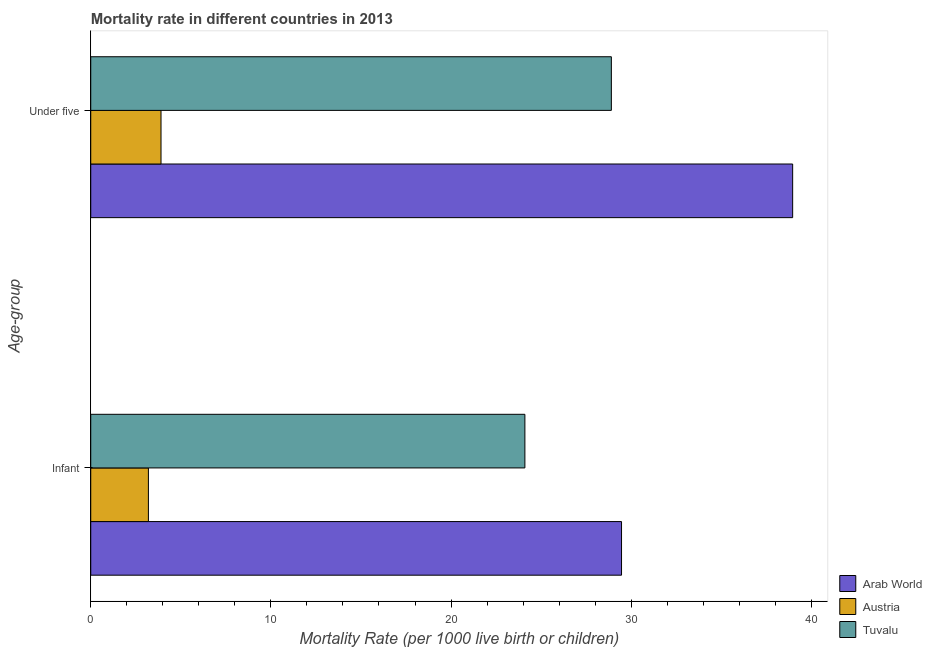Are the number of bars per tick equal to the number of legend labels?
Ensure brevity in your answer.  Yes. How many bars are there on the 1st tick from the top?
Offer a terse response. 3. How many bars are there on the 2nd tick from the bottom?
Give a very brief answer. 3. What is the label of the 1st group of bars from the top?
Keep it short and to the point. Under five. What is the infant mortality rate in Arab World?
Offer a terse response. 29.46. Across all countries, what is the maximum under-5 mortality rate?
Offer a very short reply. 38.96. In which country was the infant mortality rate maximum?
Ensure brevity in your answer.  Arab World. In which country was the infant mortality rate minimum?
Provide a short and direct response. Austria. What is the total infant mortality rate in the graph?
Your response must be concise. 56.76. What is the difference between the under-5 mortality rate in Austria and that in Arab World?
Your response must be concise. -35.06. What is the difference between the infant mortality rate in Austria and the under-5 mortality rate in Arab World?
Give a very brief answer. -35.76. What is the average infant mortality rate per country?
Give a very brief answer. 18.92. What is the difference between the infant mortality rate and under-5 mortality rate in Austria?
Give a very brief answer. -0.7. In how many countries, is the under-5 mortality rate greater than 10 ?
Provide a short and direct response. 2. What is the ratio of the under-5 mortality rate in Austria to that in Arab World?
Your answer should be very brief. 0.1. In how many countries, is the under-5 mortality rate greater than the average under-5 mortality rate taken over all countries?
Keep it short and to the point. 2. What does the 3rd bar from the top in Infant represents?
Your answer should be compact. Arab World. What does the 1st bar from the bottom in Under five represents?
Your answer should be compact. Arab World. How many bars are there?
Your answer should be very brief. 6. Are all the bars in the graph horizontal?
Offer a very short reply. Yes. How many countries are there in the graph?
Offer a terse response. 3. What is the difference between two consecutive major ticks on the X-axis?
Your answer should be compact. 10. Are the values on the major ticks of X-axis written in scientific E-notation?
Ensure brevity in your answer.  No. Where does the legend appear in the graph?
Your answer should be very brief. Bottom right. How many legend labels are there?
Provide a short and direct response. 3. How are the legend labels stacked?
Provide a short and direct response. Vertical. What is the title of the graph?
Make the answer very short. Mortality rate in different countries in 2013. Does "Turks and Caicos Islands" appear as one of the legend labels in the graph?
Give a very brief answer. No. What is the label or title of the X-axis?
Offer a very short reply. Mortality Rate (per 1000 live birth or children). What is the label or title of the Y-axis?
Offer a terse response. Age-group. What is the Mortality Rate (per 1000 live birth or children) of Arab World in Infant?
Make the answer very short. 29.46. What is the Mortality Rate (per 1000 live birth or children) in Tuvalu in Infant?
Offer a very short reply. 24.1. What is the Mortality Rate (per 1000 live birth or children) in Arab World in Under five?
Offer a very short reply. 38.96. What is the Mortality Rate (per 1000 live birth or children) in Austria in Under five?
Your response must be concise. 3.9. What is the Mortality Rate (per 1000 live birth or children) of Tuvalu in Under five?
Provide a succinct answer. 28.9. Across all Age-group, what is the maximum Mortality Rate (per 1000 live birth or children) of Arab World?
Offer a terse response. 38.96. Across all Age-group, what is the maximum Mortality Rate (per 1000 live birth or children) in Austria?
Keep it short and to the point. 3.9. Across all Age-group, what is the maximum Mortality Rate (per 1000 live birth or children) of Tuvalu?
Your response must be concise. 28.9. Across all Age-group, what is the minimum Mortality Rate (per 1000 live birth or children) in Arab World?
Provide a short and direct response. 29.46. Across all Age-group, what is the minimum Mortality Rate (per 1000 live birth or children) in Tuvalu?
Your answer should be compact. 24.1. What is the total Mortality Rate (per 1000 live birth or children) of Arab World in the graph?
Offer a very short reply. 68.43. What is the total Mortality Rate (per 1000 live birth or children) in Tuvalu in the graph?
Your answer should be compact. 53. What is the difference between the Mortality Rate (per 1000 live birth or children) in Arab World in Infant and that in Under five?
Offer a terse response. -9.5. What is the difference between the Mortality Rate (per 1000 live birth or children) of Austria in Infant and that in Under five?
Ensure brevity in your answer.  -0.7. What is the difference between the Mortality Rate (per 1000 live birth or children) of Tuvalu in Infant and that in Under five?
Provide a short and direct response. -4.8. What is the difference between the Mortality Rate (per 1000 live birth or children) of Arab World in Infant and the Mortality Rate (per 1000 live birth or children) of Austria in Under five?
Offer a terse response. 25.56. What is the difference between the Mortality Rate (per 1000 live birth or children) of Arab World in Infant and the Mortality Rate (per 1000 live birth or children) of Tuvalu in Under five?
Your answer should be very brief. 0.56. What is the difference between the Mortality Rate (per 1000 live birth or children) of Austria in Infant and the Mortality Rate (per 1000 live birth or children) of Tuvalu in Under five?
Your answer should be very brief. -25.7. What is the average Mortality Rate (per 1000 live birth or children) in Arab World per Age-group?
Provide a succinct answer. 34.21. What is the average Mortality Rate (per 1000 live birth or children) of Austria per Age-group?
Give a very brief answer. 3.55. What is the difference between the Mortality Rate (per 1000 live birth or children) of Arab World and Mortality Rate (per 1000 live birth or children) of Austria in Infant?
Offer a very short reply. 26.26. What is the difference between the Mortality Rate (per 1000 live birth or children) of Arab World and Mortality Rate (per 1000 live birth or children) of Tuvalu in Infant?
Make the answer very short. 5.36. What is the difference between the Mortality Rate (per 1000 live birth or children) of Austria and Mortality Rate (per 1000 live birth or children) of Tuvalu in Infant?
Ensure brevity in your answer.  -20.9. What is the difference between the Mortality Rate (per 1000 live birth or children) in Arab World and Mortality Rate (per 1000 live birth or children) in Austria in Under five?
Provide a succinct answer. 35.06. What is the difference between the Mortality Rate (per 1000 live birth or children) of Arab World and Mortality Rate (per 1000 live birth or children) of Tuvalu in Under five?
Ensure brevity in your answer.  10.06. What is the ratio of the Mortality Rate (per 1000 live birth or children) of Arab World in Infant to that in Under five?
Keep it short and to the point. 0.76. What is the ratio of the Mortality Rate (per 1000 live birth or children) in Austria in Infant to that in Under five?
Keep it short and to the point. 0.82. What is the ratio of the Mortality Rate (per 1000 live birth or children) of Tuvalu in Infant to that in Under five?
Offer a terse response. 0.83. What is the difference between the highest and the second highest Mortality Rate (per 1000 live birth or children) of Arab World?
Ensure brevity in your answer.  9.5. What is the difference between the highest and the second highest Mortality Rate (per 1000 live birth or children) in Tuvalu?
Provide a succinct answer. 4.8. What is the difference between the highest and the lowest Mortality Rate (per 1000 live birth or children) of Arab World?
Make the answer very short. 9.5. What is the difference between the highest and the lowest Mortality Rate (per 1000 live birth or children) in Tuvalu?
Your response must be concise. 4.8. 